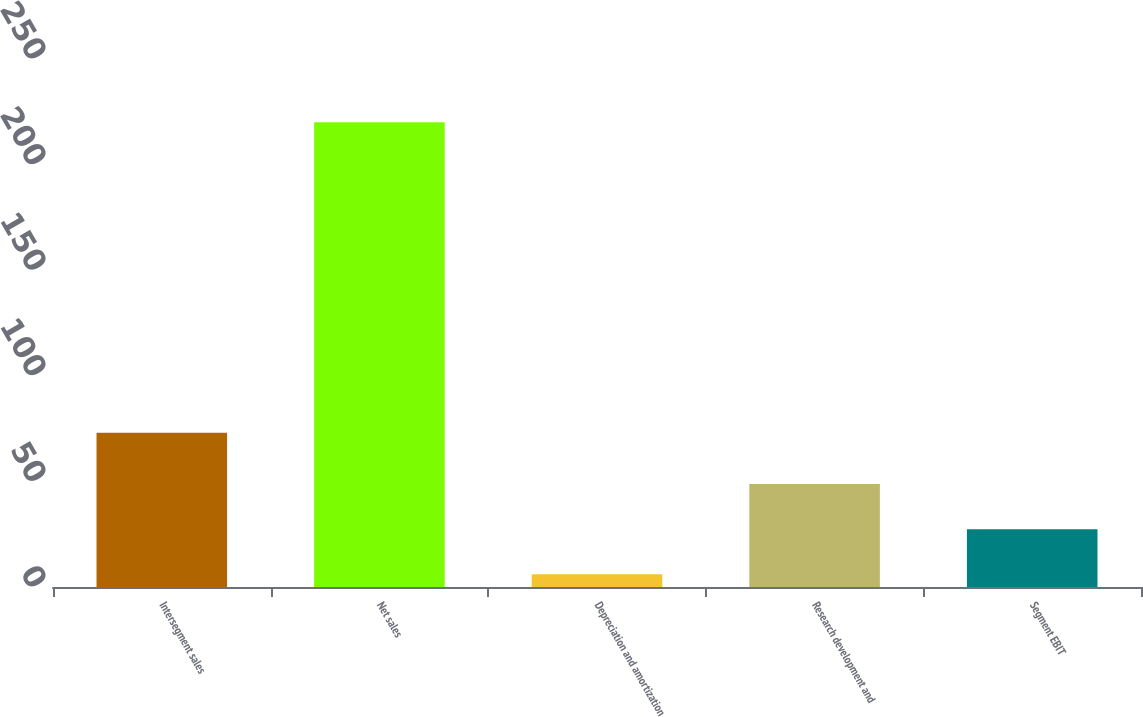<chart> <loc_0><loc_0><loc_500><loc_500><bar_chart><fcel>Intersegment sales<fcel>Net sales<fcel>Depreciation and amortization<fcel>Research development and<fcel>Segment EBIT<nl><fcel>73<fcel>220<fcel>6<fcel>48.8<fcel>27.4<nl></chart> 